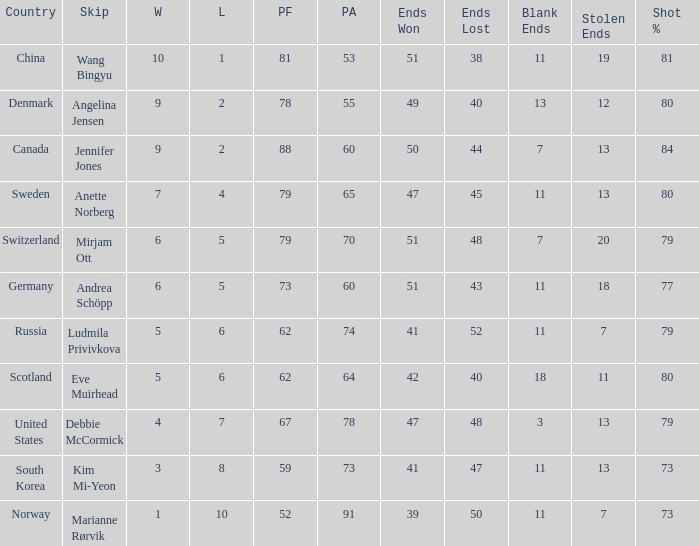When the country in question was scotland, how many goals were accomplished? 1.0. 